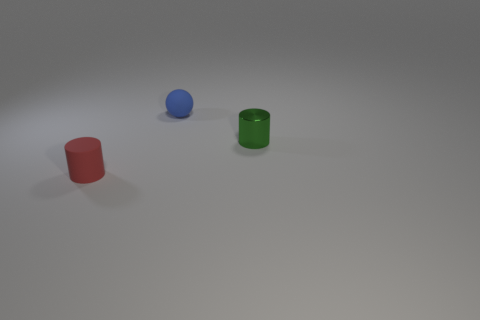Are the objects arranged in any specific pattern or randomly placed? The objects appear to be randomly placed, with no apparent pattern or alignment. 